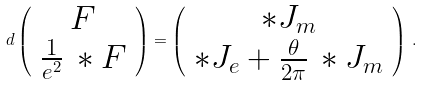<formula> <loc_0><loc_0><loc_500><loc_500>d \left ( \begin{array} { c } { F } \\ { { \frac { 1 } { e ^ { 2 } } \, * F } } \end{array} \right ) = \left ( \begin{array} { c } { { * J _ { m } } } \\ { { * J _ { e } + \frac { \theta } { 2 \pi } \, * J _ { m } } } \end{array} \right ) \, .</formula> 